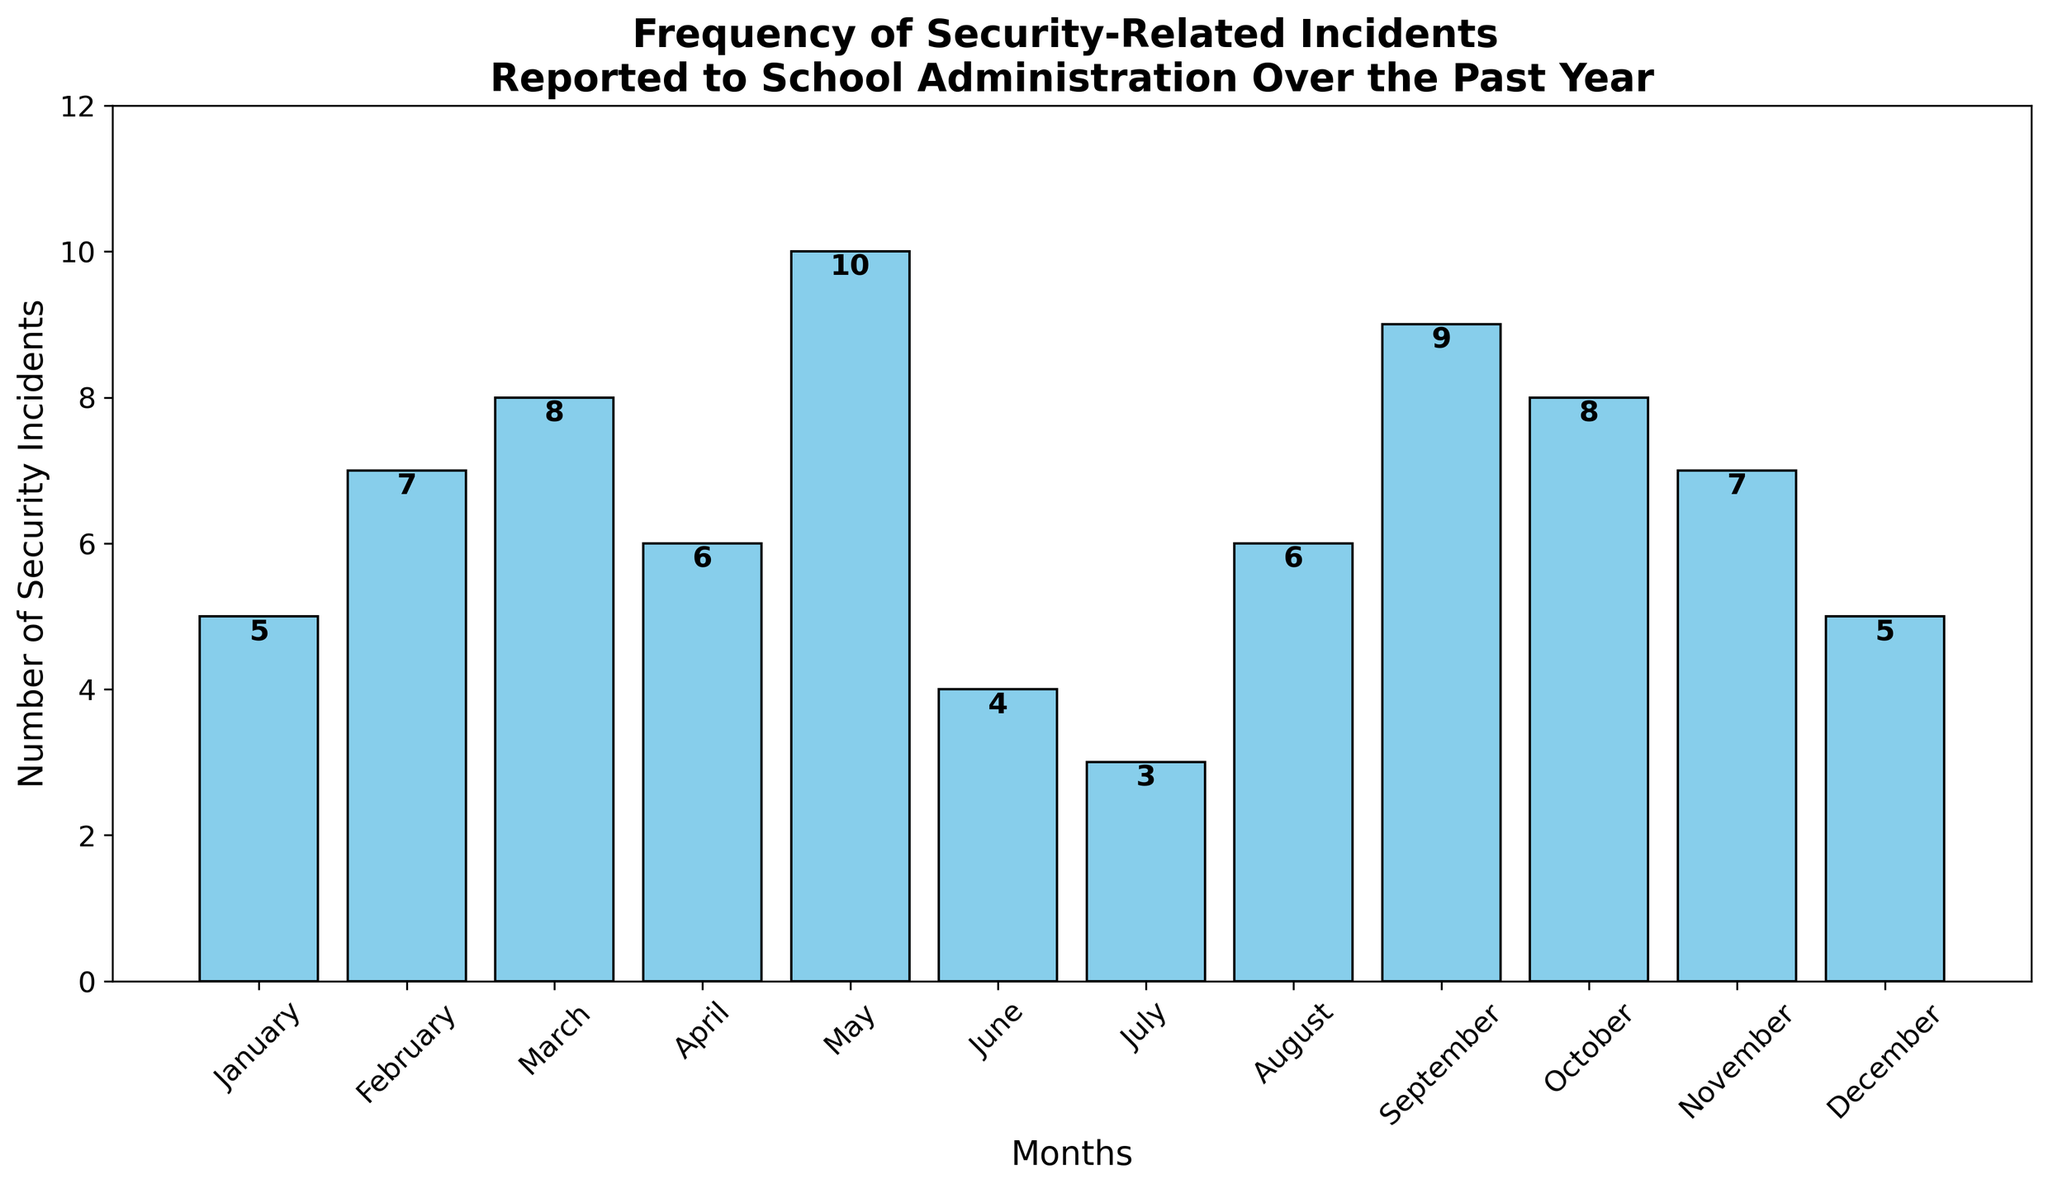Which month had the highest number of security incidents? The bar representing May is the tallest, indicating it had the highest number of incidents at 10.
Answer: May Which months had the same number of security incidents as January? The bar for January is at 5, and upon observing the figure, December also has a bar at 5.
Answer: January, December What's the difference in the number of security incidents between the month with the highest and the month with the lowest incidents? The highest number of incidents is 10 (May) and the lowest is 3 (July). The difference is 10 - 3 = 7.
Answer: 7 In which month did the number of security incidents decrease the most compared to the previous month? From May (10) to June (4), the incidents decreased by 6, which is the largest drop compared to any other consecutive months.
Answer: June What is the average number of security incidents per month? Sum all the incidents (5+7+8+6+10+4+3+6+9+8+7+5) = 78. There are 12 months, so the average is 78/12 = 6.5.
Answer: 6.5 How many more incidents occurred in September compared to July? July had 3 incidents, while September had 9. The difference is 9 - 3 = 6.
Answer: 6 Which month experienced the highest increase in security incidents compared to the previous month? From April (6) to May (10), the incidents increased by 4, which is the largest increase compared to any other consecutive months.
Answer: May Is the frequency of incidents higher in the second half of the year (July to December) compared to the first half (January to June)? Sum of incidents from January to June is 5+7+8+6+10+4 = 40. Sum from July to December is 3+6+9+8+7+5 = 38. The first half of the year has 40 incidents, which is more than the 38 incidents in the second half.
Answer: No What is the median number of incidents reported per month? Arranging the incidents in ascending order: 3, 4, 5, 5, 6, 6, 7, 7, 8, 8, 9, 10. The middle values are 6 and 7, so the median is (6+7)/2 = 6.5.
Answer: 6.5 Which months experienced the same frequency of incidents as February? February had 7 incidents. Both November and October also had 7 incidents.
Answer: February, November, October 